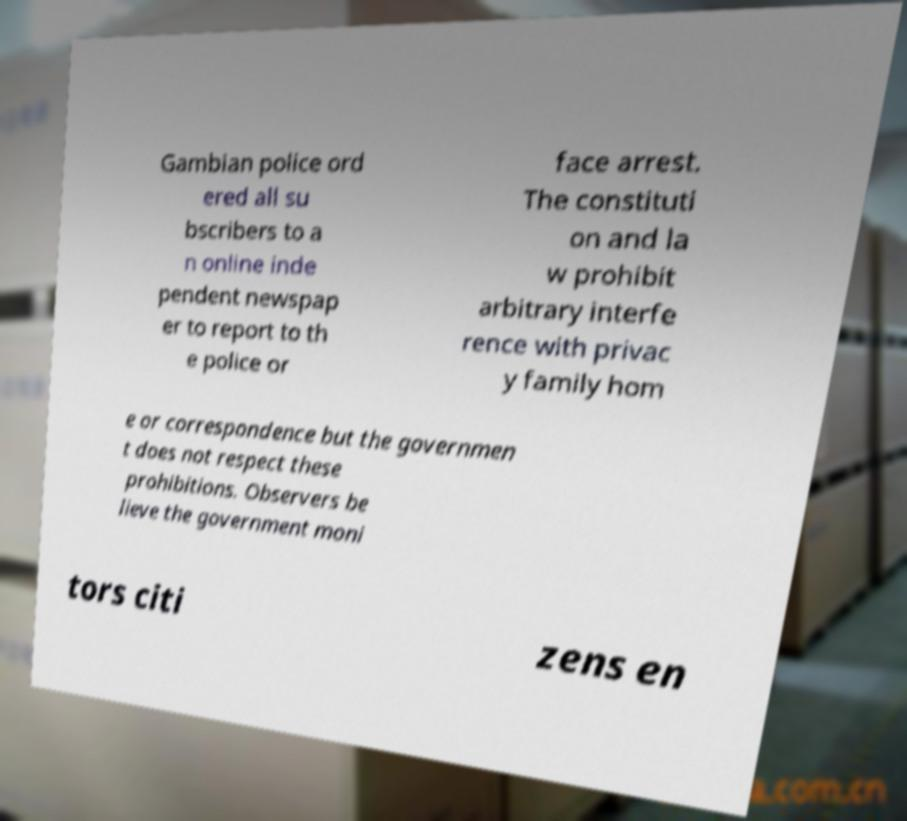Could you assist in decoding the text presented in this image and type it out clearly? Gambian police ord ered all su bscribers to a n online inde pendent newspap er to report to th e police or face arrest. The constituti on and la w prohibit arbitrary interfe rence with privac y family hom e or correspondence but the governmen t does not respect these prohibitions. Observers be lieve the government moni tors citi zens en 